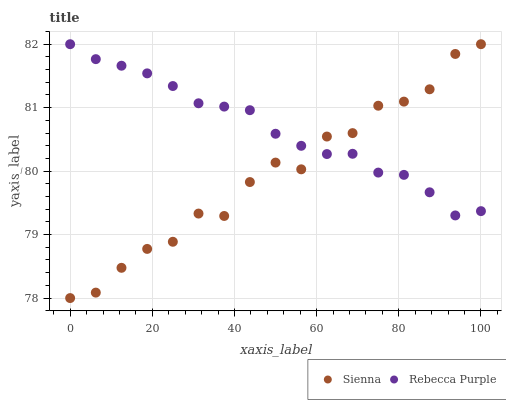Does Sienna have the minimum area under the curve?
Answer yes or no. Yes. Does Rebecca Purple have the maximum area under the curve?
Answer yes or no. Yes. Does Rebecca Purple have the minimum area under the curve?
Answer yes or no. No. Is Rebecca Purple the smoothest?
Answer yes or no. Yes. Is Sienna the roughest?
Answer yes or no. Yes. Is Rebecca Purple the roughest?
Answer yes or no. No. Does Sienna have the lowest value?
Answer yes or no. Yes. Does Rebecca Purple have the lowest value?
Answer yes or no. No. Does Rebecca Purple have the highest value?
Answer yes or no. Yes. Does Rebecca Purple intersect Sienna?
Answer yes or no. Yes. Is Rebecca Purple less than Sienna?
Answer yes or no. No. Is Rebecca Purple greater than Sienna?
Answer yes or no. No. 